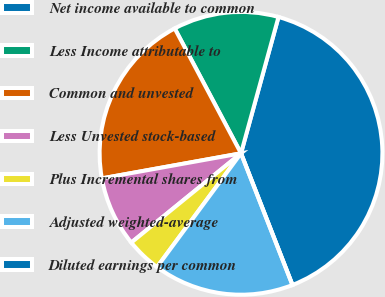<chart> <loc_0><loc_0><loc_500><loc_500><pie_chart><fcel>Net income available to common<fcel>Less Income attributable to<fcel>Common and unvested<fcel>Less Unvested stock-based<fcel>Plus Incremental shares from<fcel>Adjusted weighted-average<fcel>Diluted earnings per common<nl><fcel>39.8%<fcel>12.04%<fcel>20.07%<fcel>8.03%<fcel>4.01%<fcel>16.05%<fcel>0.0%<nl></chart> 